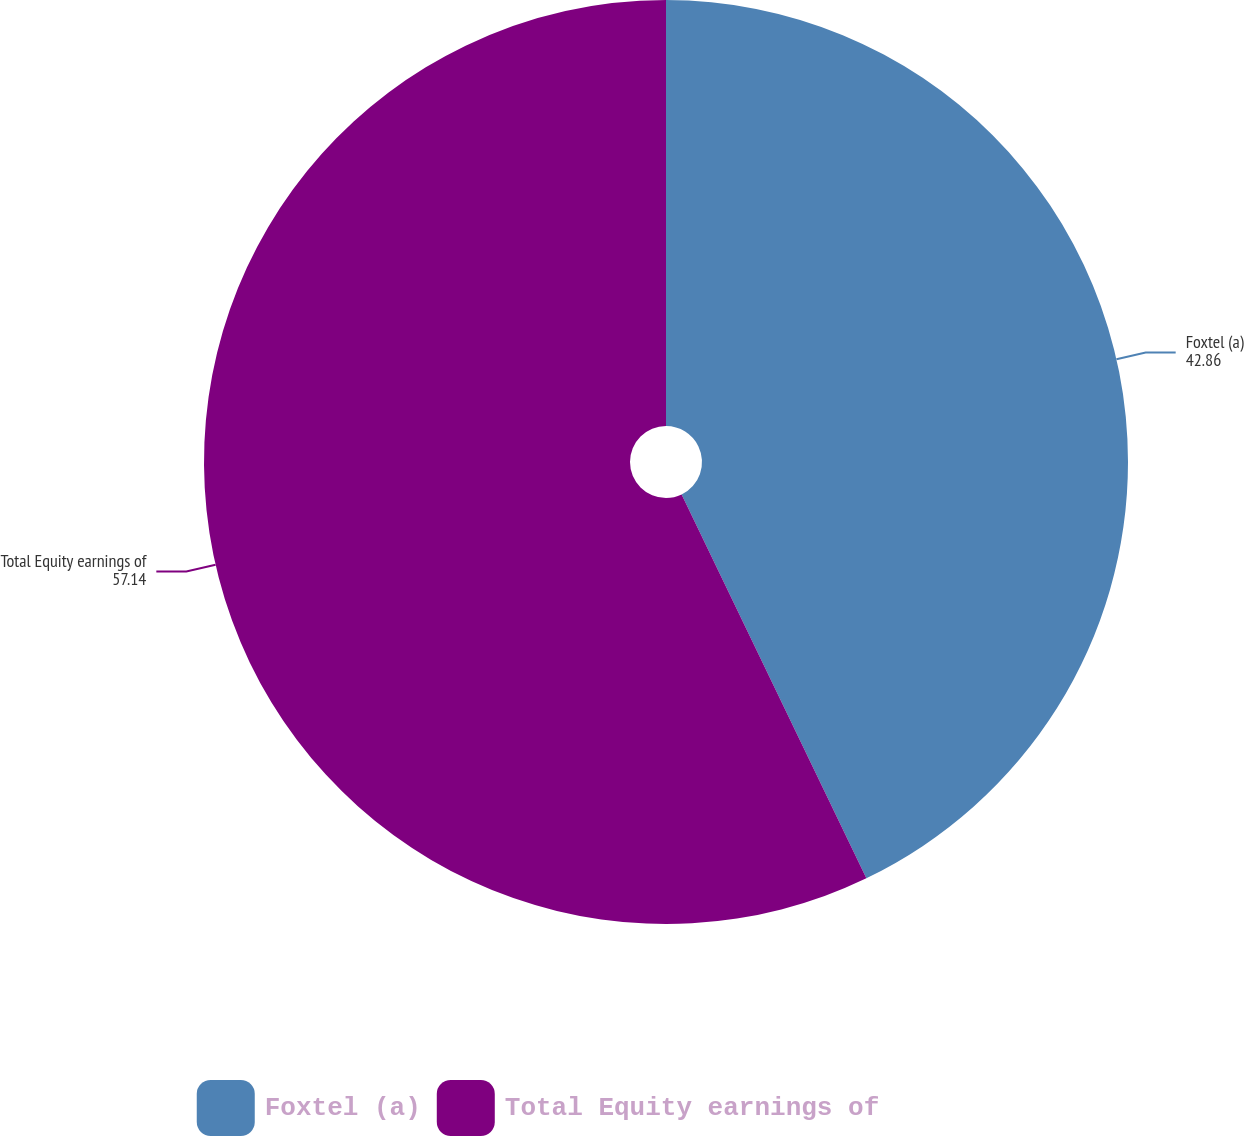Convert chart to OTSL. <chart><loc_0><loc_0><loc_500><loc_500><pie_chart><fcel>Foxtel (a)<fcel>Total Equity earnings of<nl><fcel>42.86%<fcel>57.14%<nl></chart> 